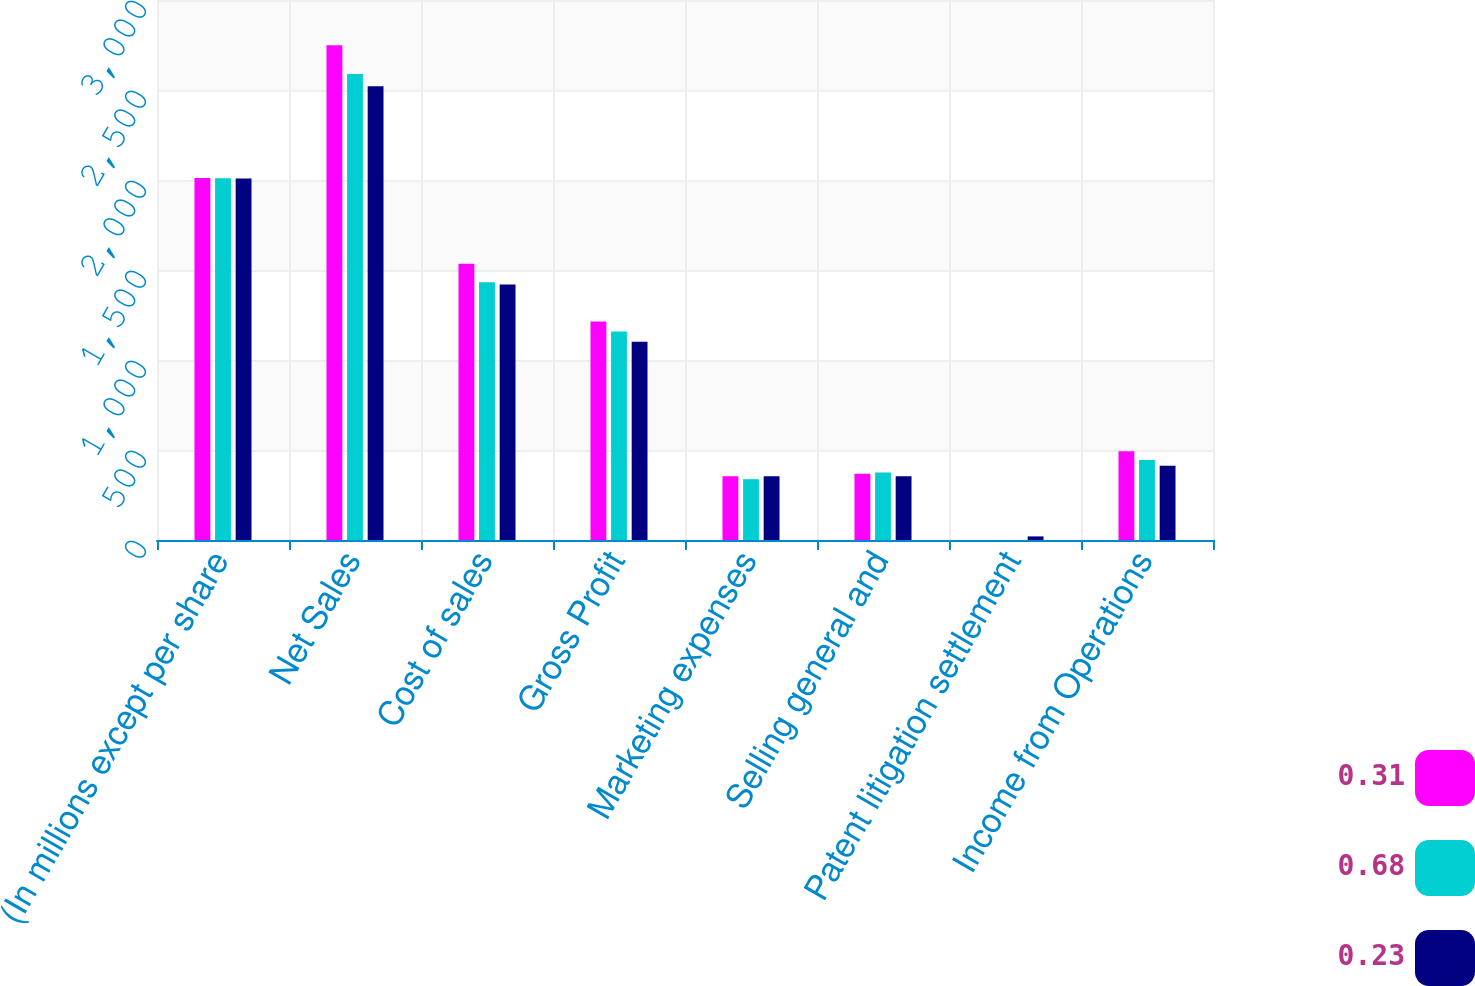Convert chart to OTSL. <chart><loc_0><loc_0><loc_500><loc_500><stacked_bar_chart><ecel><fcel>(In millions except per share<fcel>Net Sales<fcel>Cost of sales<fcel>Gross Profit<fcel>Marketing expenses<fcel>Selling general and<fcel>Patent litigation settlement<fcel>Income from Operations<nl><fcel>0.31<fcel>2011<fcel>2749.3<fcel>1534.8<fcel>1214.5<fcel>354.1<fcel>367.8<fcel>0<fcel>492.6<nl><fcel>0.68<fcel>2010<fcel>2589.2<fcel>1431.4<fcel>1157.8<fcel>338<fcel>374.8<fcel>0<fcel>445<nl><fcel>0.23<fcel>2009<fcel>2520.9<fcel>1419.9<fcel>1101<fcel>353.6<fcel>354.5<fcel>20<fcel>412.9<nl></chart> 